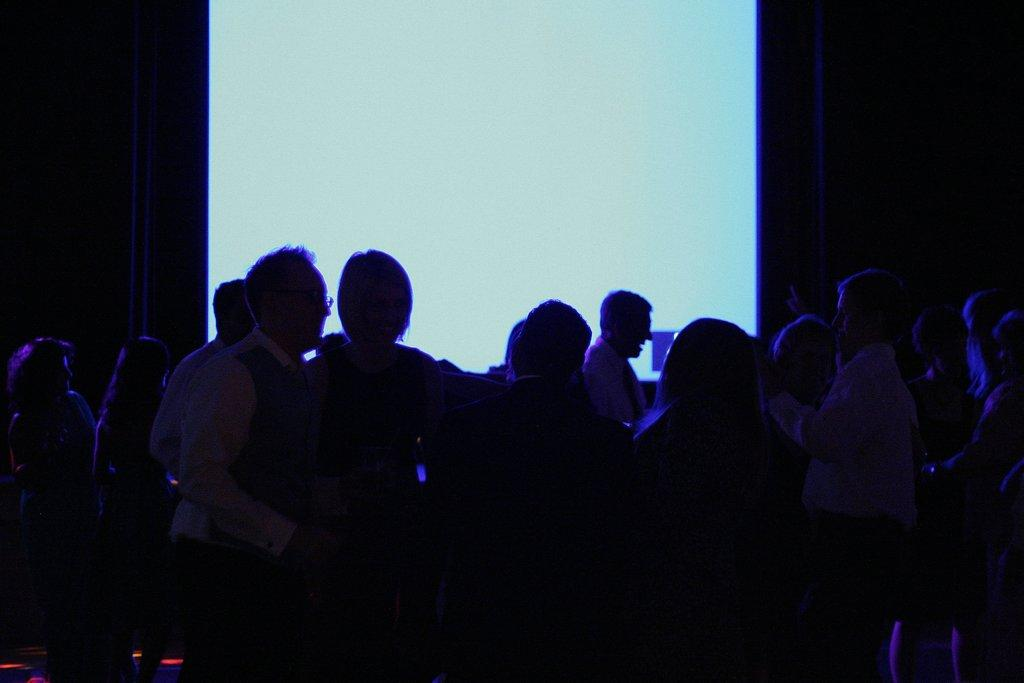What is the overall lighting condition of the image? The image is dark. How many people can be seen in the image? There are multiple persons standing in the image. What can be seen in the background of the image? There is a screen visible in the background. How would you describe the overall color scheme of the image? The background of the image is dark, and the overall lighting condition is also dark. What decision was made by the circle in the image? There is no circle present in the image, and therefore no decision can be attributed to it. 